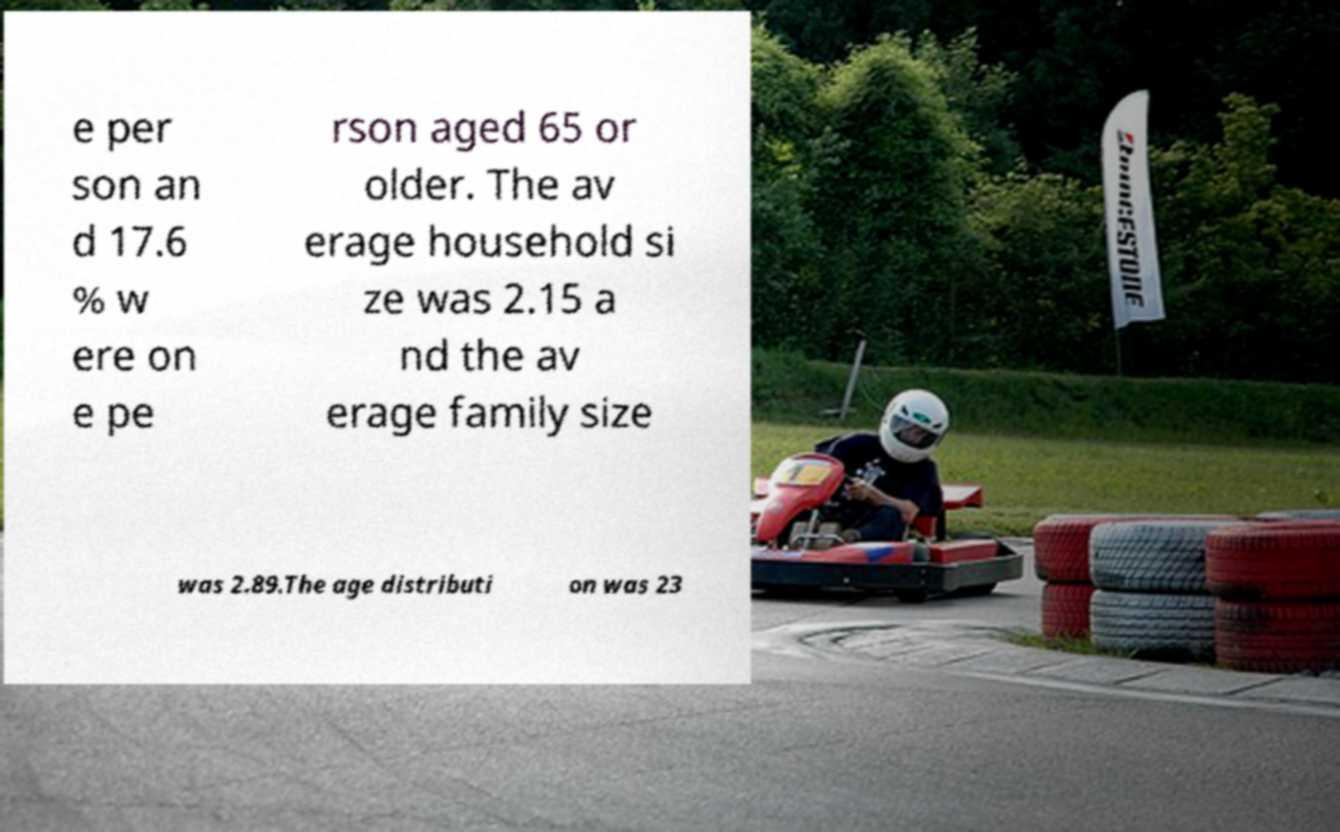Can you read and provide the text displayed in the image?This photo seems to have some interesting text. Can you extract and type it out for me? e per son an d 17.6 % w ere on e pe rson aged 65 or older. The av erage household si ze was 2.15 a nd the av erage family size was 2.89.The age distributi on was 23 